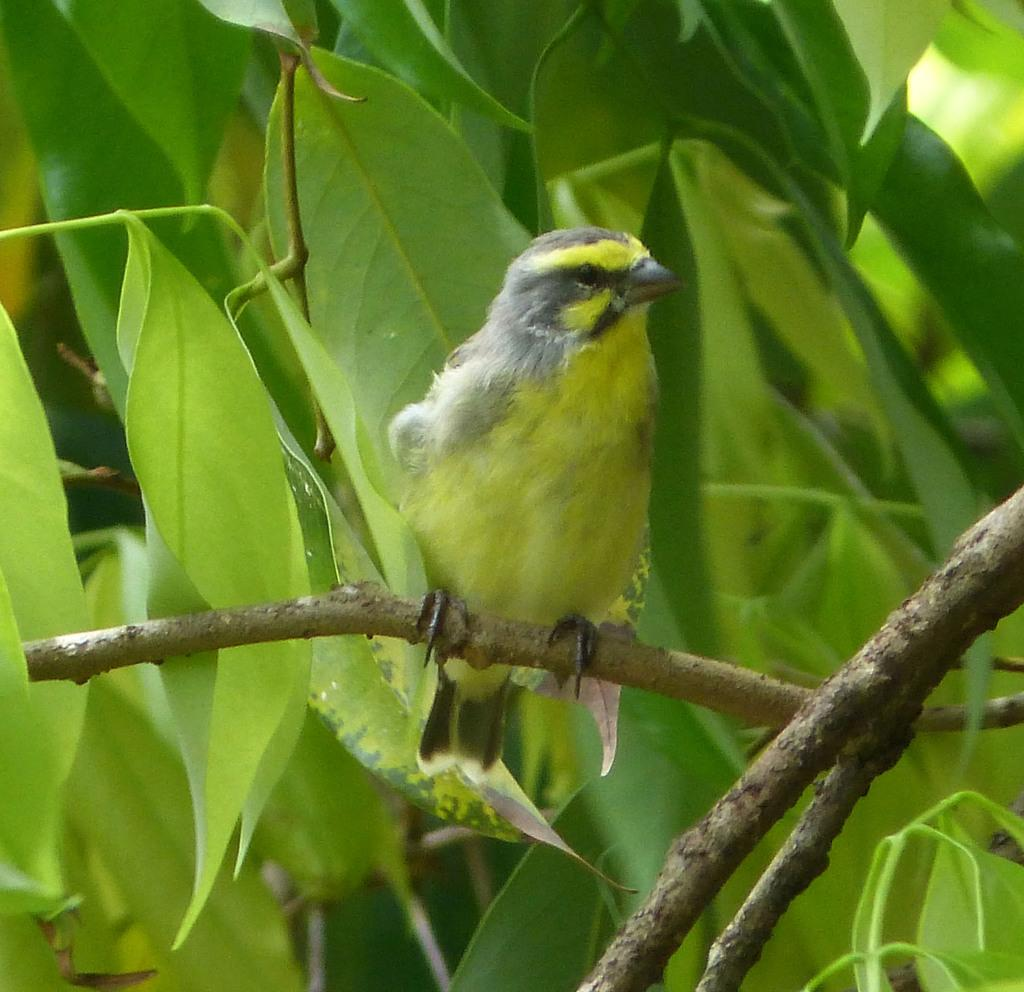What is the main subject in the center of the image? There is a bird in the center of the image. Where is the bird located? The bird is on a stem. What can be seen in the background of the image? There are leaves in the background of the image. What type of ink is used to write the bird's name on the stem? There is no ink or writing present in the image, so it is not possible to determine the type of ink used. 